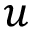Convert formula to latex. <formula><loc_0><loc_0><loc_500><loc_500>u</formula> 